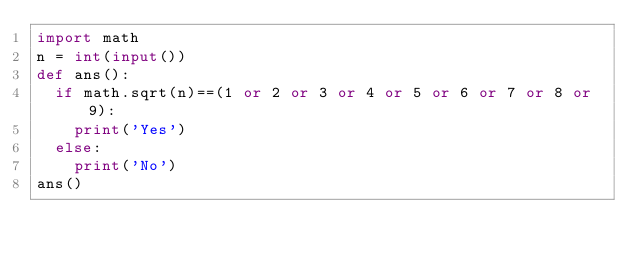Convert code to text. <code><loc_0><loc_0><loc_500><loc_500><_Python_>import math
n = int(input())
def ans():
  if math.sqrt(n)==(1 or 2 or 3 or 4 or 5 or 6 or 7 or 8 or 9):
    print('Yes')
  else:
    print('No')
ans()

</code> 